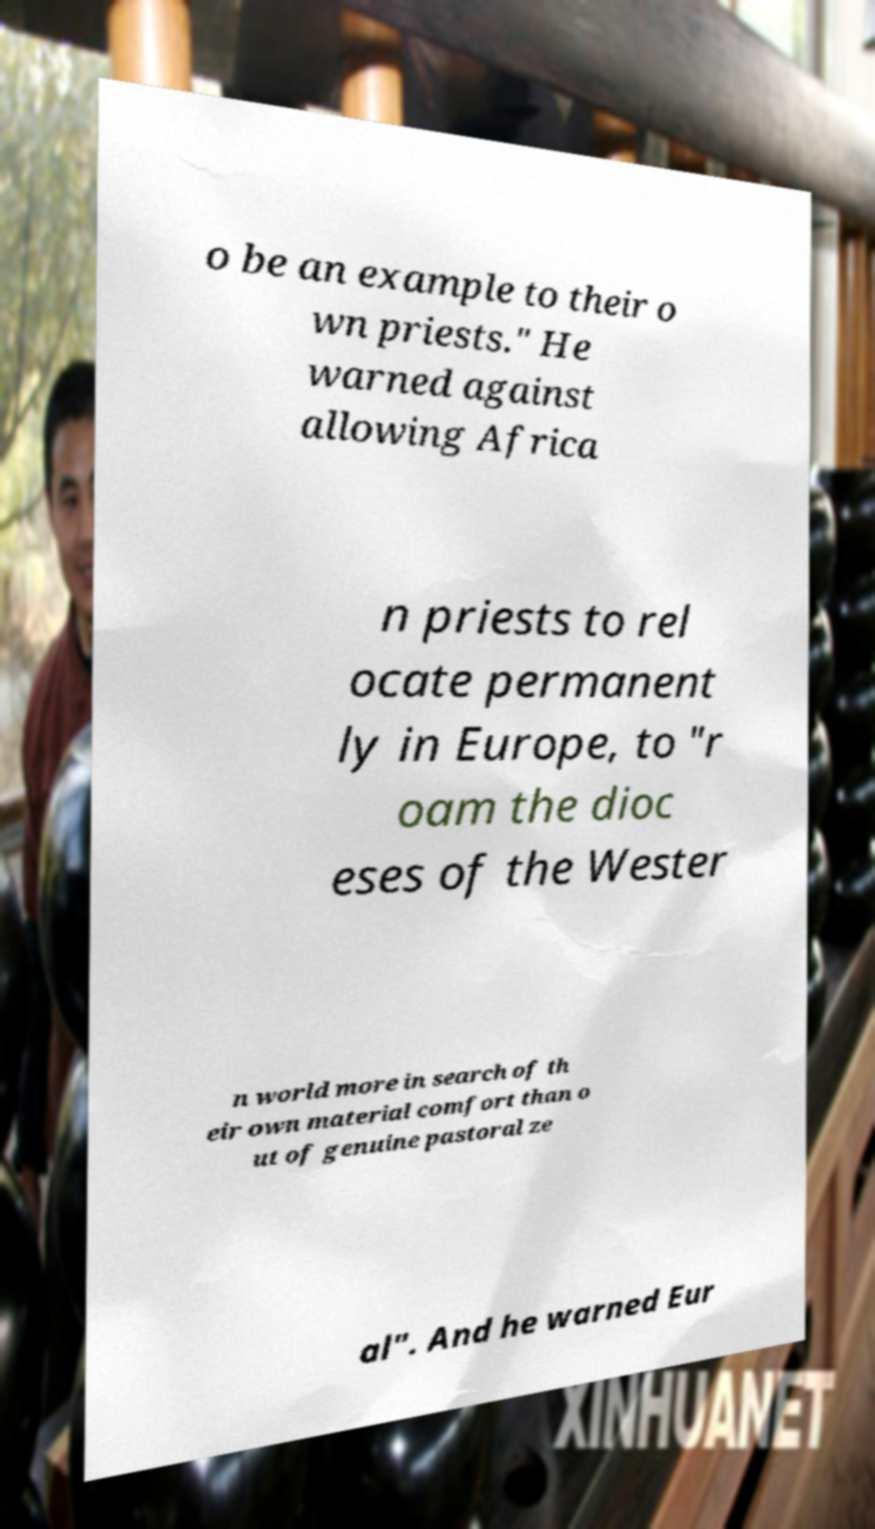Can you accurately transcribe the text from the provided image for me? o be an example to their o wn priests." He warned against allowing Africa n priests to rel ocate permanent ly in Europe, to "r oam the dioc eses of the Wester n world more in search of th eir own material comfort than o ut of genuine pastoral ze al". And he warned Eur 